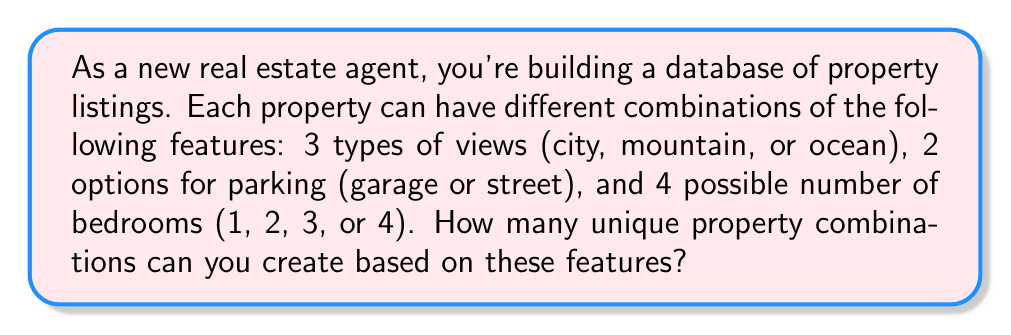Could you help me with this problem? To solve this problem, we'll use the multiplication principle of counting. This principle states that if we have multiple independent choices, the total number of possible outcomes is the product of the number of choices for each option.

Let's break down the problem:

1. Views: There are 3 types of views (city, mountain, or ocean)
   $n_1 = 3$

2. Parking: There are 2 options for parking (garage or street)
   $n_2 = 2$

3. Bedrooms: There are 4 possible numbers of bedrooms (1, 2, 3, or 4)
   $n_3 = 4$

Now, we apply the multiplication principle:

Total number of combinations = $n_1 \times n_2 \times n_3$

Substituting the values:

$$ \text{Total combinations} = 3 \times 2 \times 4 = 24 $$

Therefore, there are 24 unique property combinations based on the given features.
Answer: 24 